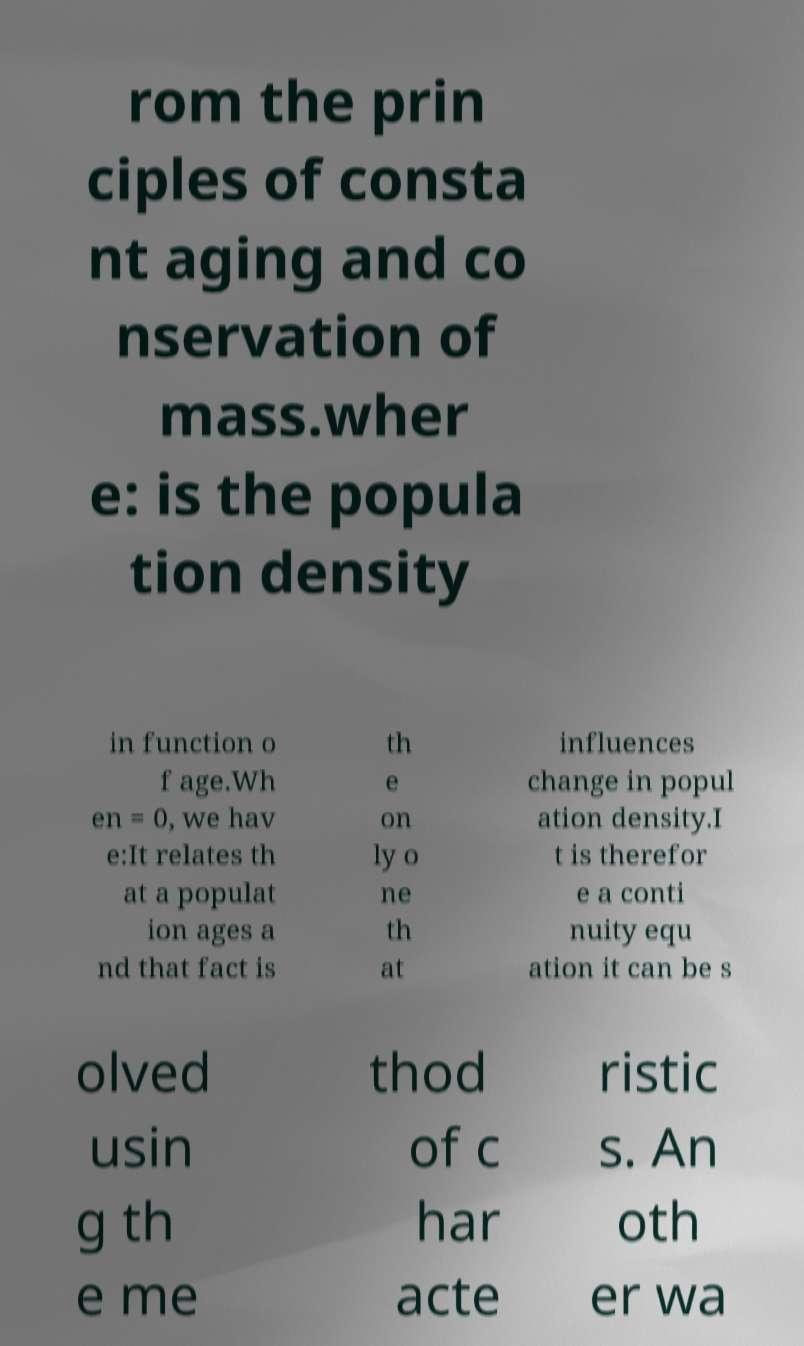Could you assist in decoding the text presented in this image and type it out clearly? rom the prin ciples of consta nt aging and co nservation of mass.wher e: is the popula tion density in function o f age.Wh en = 0, we hav e:It relates th at a populat ion ages a nd that fact is th e on ly o ne th at influences change in popul ation density.I t is therefor e a conti nuity equ ation it can be s olved usin g th e me thod of c har acte ristic s. An oth er wa 